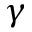Convert formula to latex. <formula><loc_0><loc_0><loc_500><loc_500>\gamma</formula> 